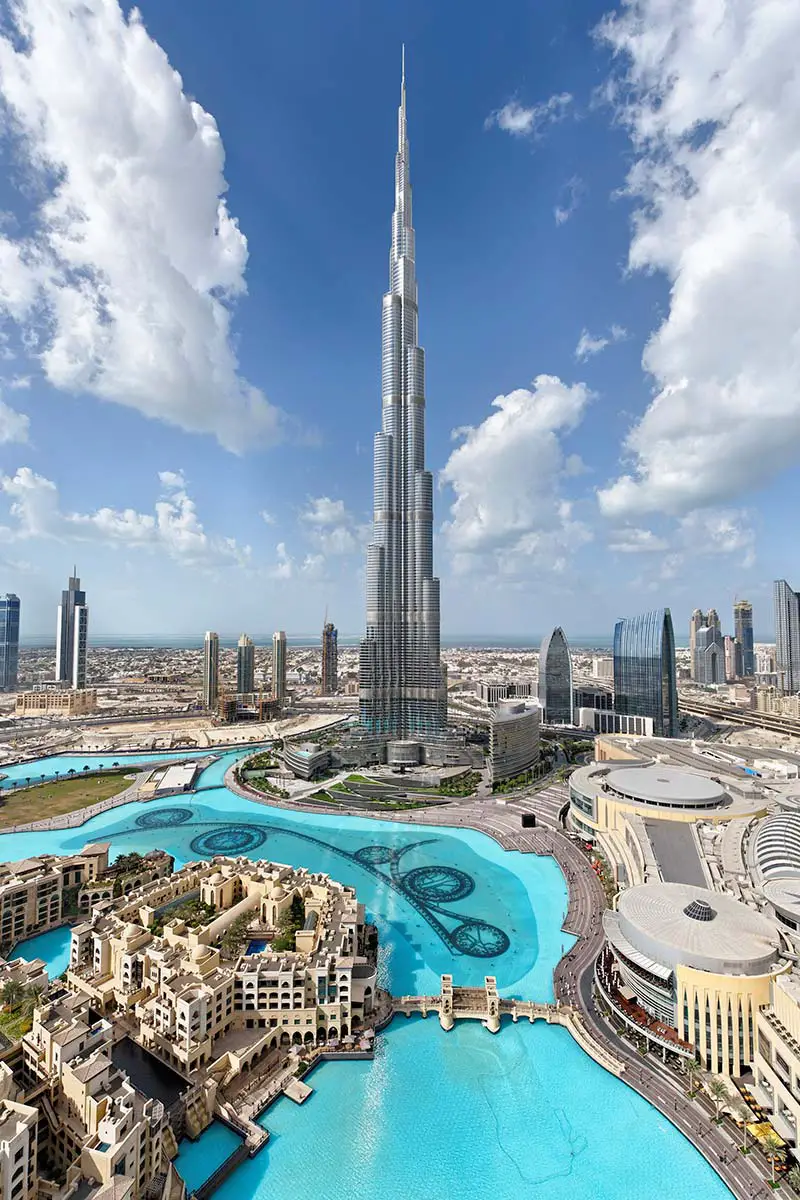What are the key elements in this picture? The image prominently features the awe-inspiring Burj Khalifa, the tallest building in the world, rising majestically in Dubai, United Arab Emirates. Taken from an elevated perspective, the photograph offers a sweeping view of Dubai's modern skyline, characterized by a mix of high-rise skyscrapers and meticulously planned road networks. At the forefront, the sparkling blue-green waters of an expansive fountain and artificial lake add a touch of natural beauty to the urban scene. The Burj Khalifa itself stands as an iconic silver spire, its tiered design tapering to a sharp pinnacle that pierces the clear blue sky, which is dotted with a scattering of fluffy white clouds. This serene sky forms a tranquil backdrop to the bustling city life below, capturing the dynamic harmony between nature and urbanity. 